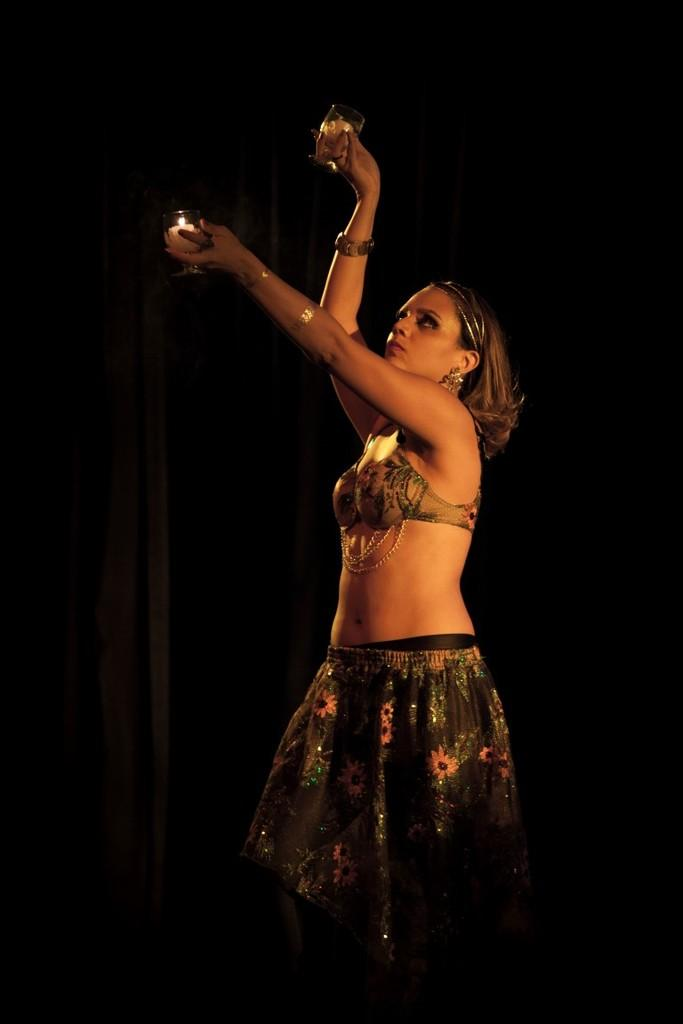What is the main subject of the image? The main subject of the image is a woman. What is the woman doing in the image? The woman is standing in the image. What is the woman holding in the image? The woman is holding two glasses in the image. What type of scarf is the woman wearing in the image? There is no scarf visible in the image. Can you see a nest in the background of the image? There is no nest present in the image. 